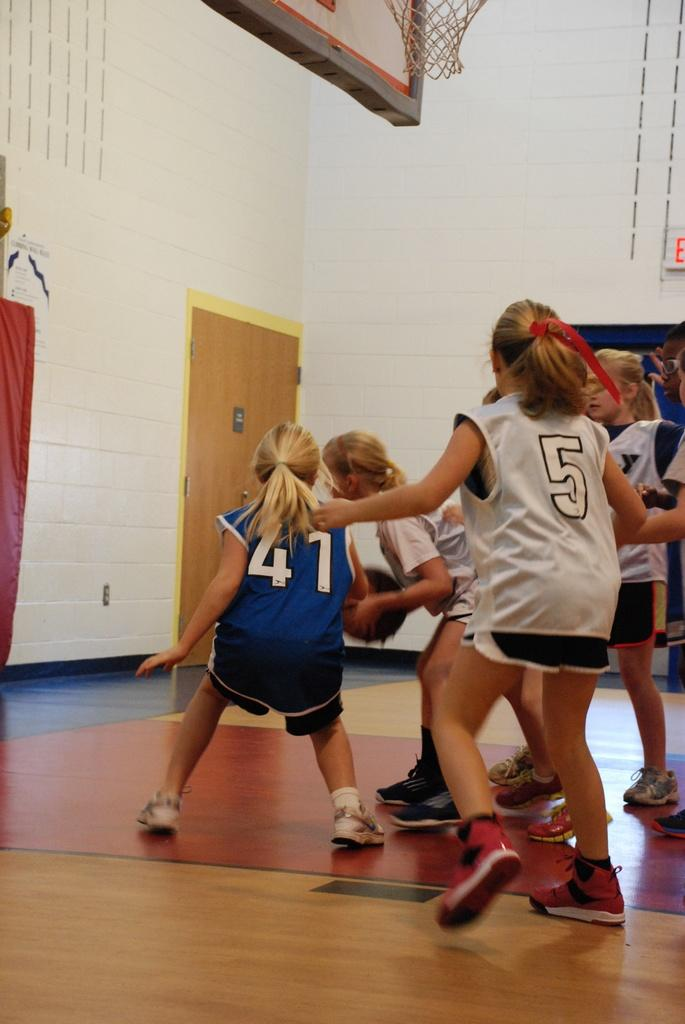<image>
Summarize the visual content of the image. Girls playing basketball wearing number 41 and 5 jerseys 